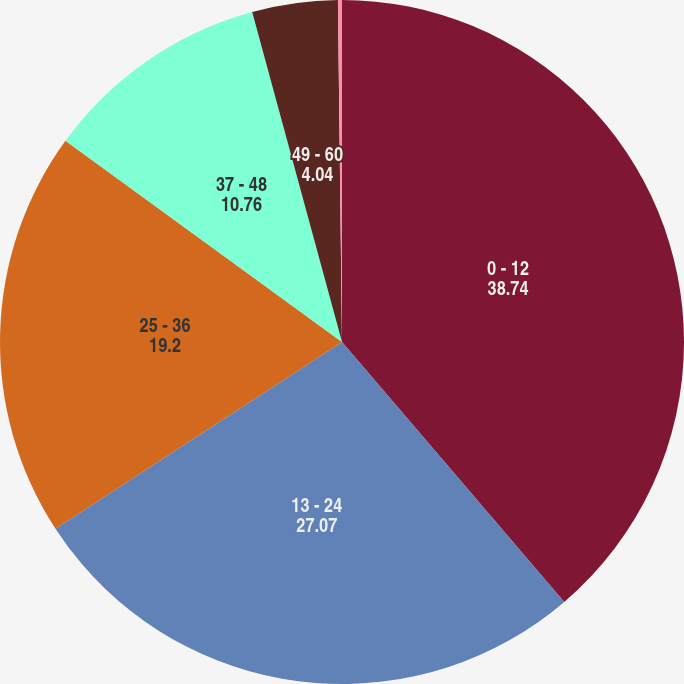Convert chart. <chart><loc_0><loc_0><loc_500><loc_500><pie_chart><fcel>0 - 12<fcel>13 - 24<fcel>25 - 36<fcel>37 - 48<fcel>49 - 60<fcel>Thereafter<nl><fcel>38.74%<fcel>27.07%<fcel>19.2%<fcel>10.76%<fcel>4.04%<fcel>0.19%<nl></chart> 